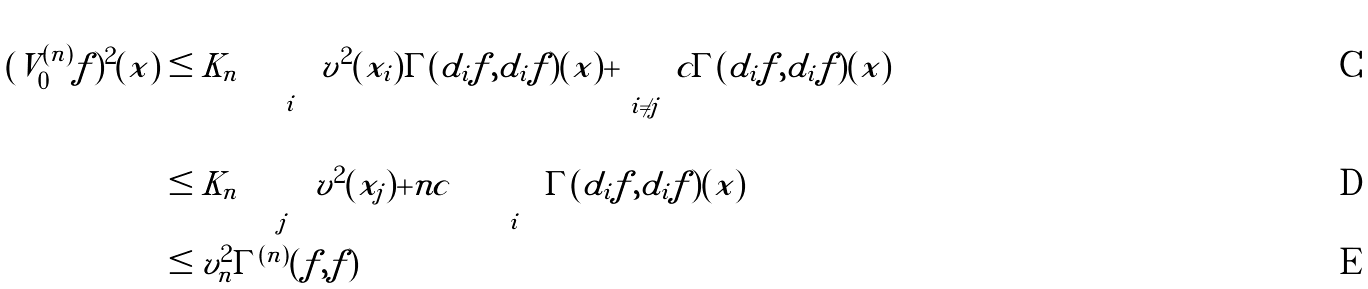<formula> <loc_0><loc_0><loc_500><loc_500>( V _ { 0 } ^ { ( n ) } f ) ^ { 2 } ( x ) & \leq K _ { n } \left ( \sum _ { i } v ^ { 2 } ( x _ { i } ) \Gamma ( d _ { i } f , d _ { i } f ) ( x ) + \sum _ { i \ne j } c \Gamma ( d _ { i } f , d _ { i } f ) ( x ) \right ) \\ & \leq K _ { n } \left ( \sum _ { j } v ^ { 2 } ( x _ { j } ) + n c \right ) \left ( \sum _ { i } \Gamma ( d _ { i } f , d _ { i } f ) ( x ) \right ) \\ & \leq v _ { n } ^ { 2 } \Gamma ^ { ( n ) } ( f , f )</formula> 